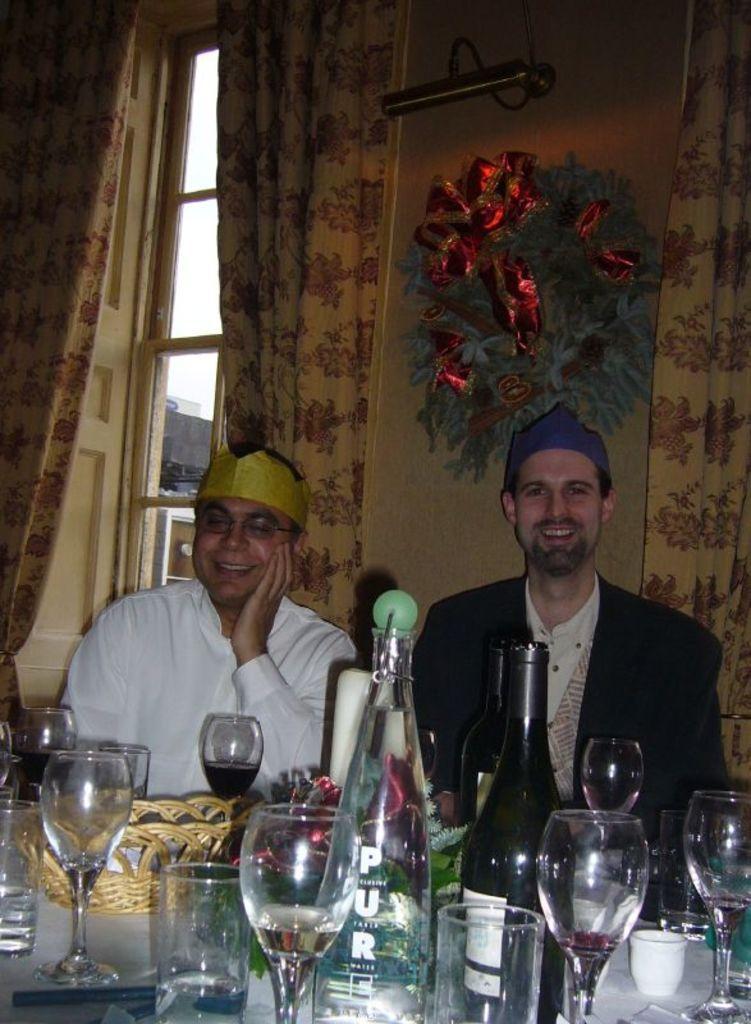In one or two sentences, can you explain what this image depicts? In this image there are two persons. Both are smiling they are wearing blue cap and yellow cap. In front of them on the table there are bottles, glasses,basket. In the background there is a painting ,window and curtain. 